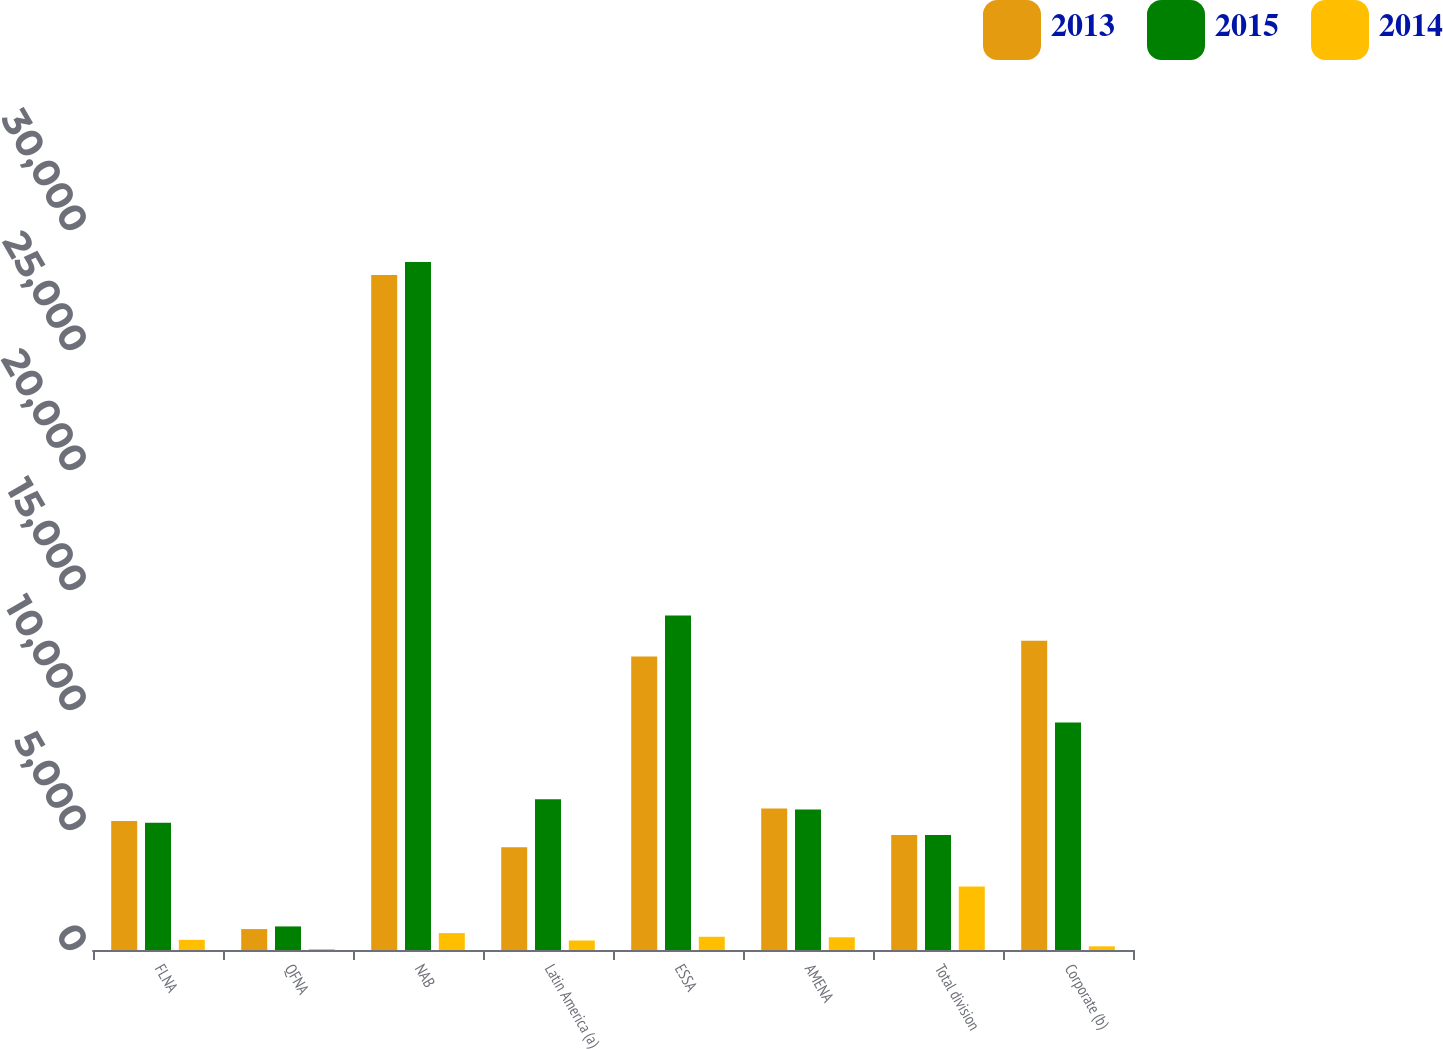<chart> <loc_0><loc_0><loc_500><loc_500><stacked_bar_chart><ecel><fcel>FLNA<fcel>QFNA<fcel>NAB<fcel>Latin America (a)<fcel>ESSA<fcel>AMENA<fcel>Total division<fcel>Corporate (b)<nl><fcel>2013<fcel>5375<fcel>872<fcel>28128<fcel>4284<fcel>12225<fcel>5901<fcel>4795.5<fcel>12882<nl><fcel>2015<fcel>5307<fcel>982<fcel>28665<fcel>6283<fcel>13934<fcel>5855<fcel>4795.5<fcel>9483<nl><fcel>2014<fcel>423<fcel>38<fcel>705<fcel>395<fcel>551<fcel>530<fcel>2642<fcel>153<nl></chart> 